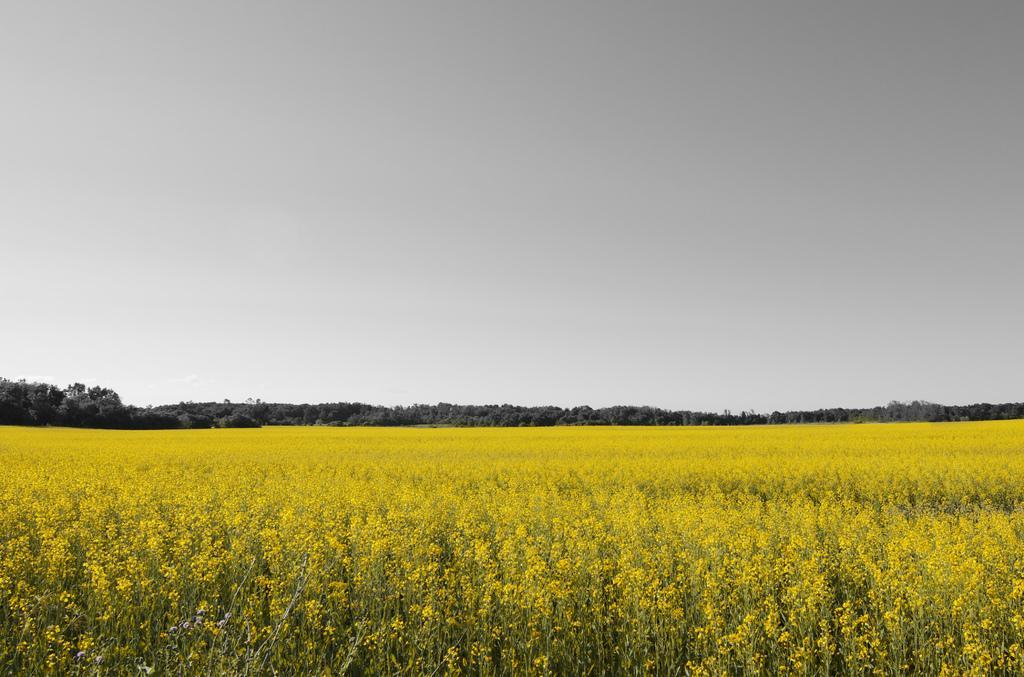How would you summarize this image in a sentence or two? In this image at the bottom we can see plants with flowers. In the background there are trees and the sky. 